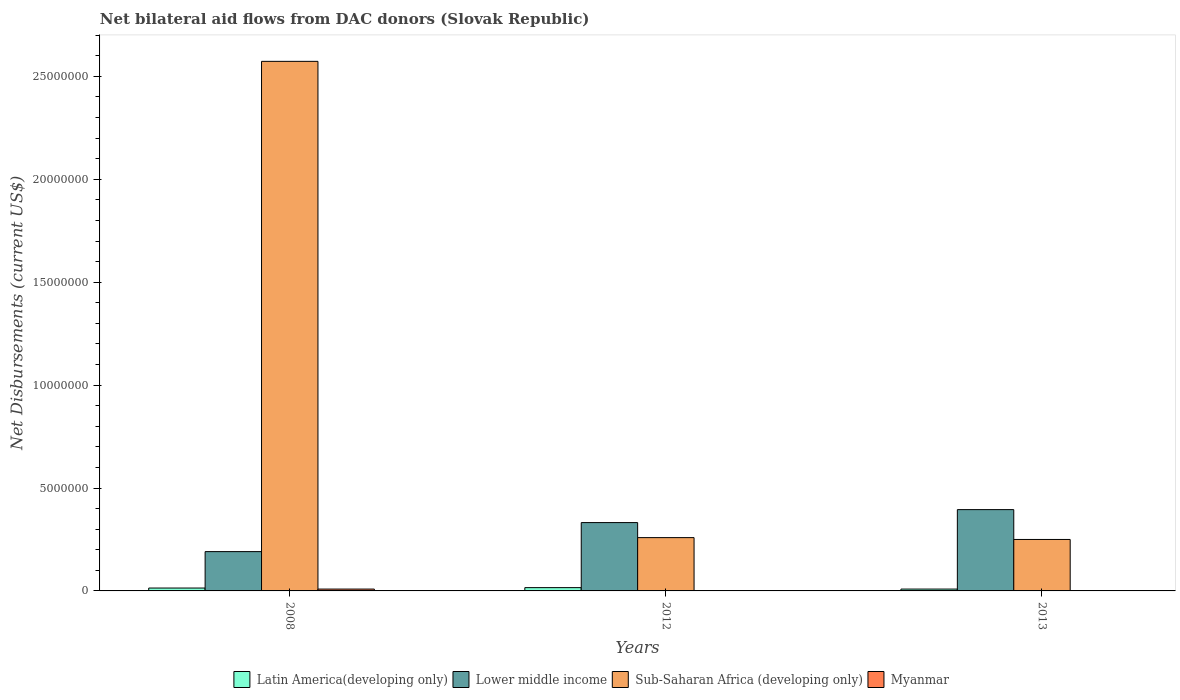Are the number of bars on each tick of the X-axis equal?
Keep it short and to the point. Yes. How many bars are there on the 3rd tick from the left?
Provide a succinct answer. 4. How many bars are there on the 3rd tick from the right?
Keep it short and to the point. 4. What is the label of the 1st group of bars from the left?
Provide a succinct answer. 2008. In how many cases, is the number of bars for a given year not equal to the number of legend labels?
Keep it short and to the point. 0. What is the net bilateral aid flows in Sub-Saharan Africa (developing only) in 2008?
Provide a succinct answer. 2.57e+07. Across all years, what is the minimum net bilateral aid flows in Sub-Saharan Africa (developing only)?
Offer a terse response. 2.50e+06. What is the difference between the net bilateral aid flows in Lower middle income in 2008 and the net bilateral aid flows in Sub-Saharan Africa (developing only) in 2013?
Offer a very short reply. -5.90e+05. In the year 2012, what is the difference between the net bilateral aid flows in Latin America(developing only) and net bilateral aid flows in Lower middle income?
Your answer should be compact. -3.16e+06. What is the ratio of the net bilateral aid flows in Lower middle income in 2012 to that in 2013?
Provide a succinct answer. 0.84. What is the difference between the highest and the lowest net bilateral aid flows in Myanmar?
Keep it short and to the point. 7.00e+04. In how many years, is the net bilateral aid flows in Latin America(developing only) greater than the average net bilateral aid flows in Latin America(developing only) taken over all years?
Your response must be concise. 2. What does the 1st bar from the left in 2008 represents?
Give a very brief answer. Latin America(developing only). What does the 1st bar from the right in 2012 represents?
Keep it short and to the point. Myanmar. Is it the case that in every year, the sum of the net bilateral aid flows in Lower middle income and net bilateral aid flows in Sub-Saharan Africa (developing only) is greater than the net bilateral aid flows in Latin America(developing only)?
Your answer should be compact. Yes. Are all the bars in the graph horizontal?
Ensure brevity in your answer.  No. How many years are there in the graph?
Provide a succinct answer. 3. Are the values on the major ticks of Y-axis written in scientific E-notation?
Keep it short and to the point. No. Does the graph contain grids?
Offer a very short reply. No. How many legend labels are there?
Make the answer very short. 4. How are the legend labels stacked?
Your answer should be compact. Horizontal. What is the title of the graph?
Your answer should be very brief. Net bilateral aid flows from DAC donors (Slovak Republic). Does "Tuvalu" appear as one of the legend labels in the graph?
Offer a very short reply. No. What is the label or title of the Y-axis?
Provide a succinct answer. Net Disbursements (current US$). What is the Net Disbursements (current US$) in Latin America(developing only) in 2008?
Ensure brevity in your answer.  1.40e+05. What is the Net Disbursements (current US$) in Lower middle income in 2008?
Ensure brevity in your answer.  1.91e+06. What is the Net Disbursements (current US$) of Sub-Saharan Africa (developing only) in 2008?
Offer a terse response. 2.57e+07. What is the Net Disbursements (current US$) in Myanmar in 2008?
Make the answer very short. 9.00e+04. What is the Net Disbursements (current US$) in Latin America(developing only) in 2012?
Your response must be concise. 1.60e+05. What is the Net Disbursements (current US$) in Lower middle income in 2012?
Your response must be concise. 3.32e+06. What is the Net Disbursements (current US$) in Sub-Saharan Africa (developing only) in 2012?
Offer a very short reply. 2.59e+06. What is the Net Disbursements (current US$) in Lower middle income in 2013?
Offer a terse response. 3.95e+06. What is the Net Disbursements (current US$) of Sub-Saharan Africa (developing only) in 2013?
Your answer should be very brief. 2.50e+06. What is the Net Disbursements (current US$) in Myanmar in 2013?
Your response must be concise. 2.00e+04. Across all years, what is the maximum Net Disbursements (current US$) in Latin America(developing only)?
Give a very brief answer. 1.60e+05. Across all years, what is the maximum Net Disbursements (current US$) of Lower middle income?
Provide a succinct answer. 3.95e+06. Across all years, what is the maximum Net Disbursements (current US$) of Sub-Saharan Africa (developing only)?
Provide a succinct answer. 2.57e+07. Across all years, what is the minimum Net Disbursements (current US$) of Lower middle income?
Provide a succinct answer. 1.91e+06. Across all years, what is the minimum Net Disbursements (current US$) of Sub-Saharan Africa (developing only)?
Give a very brief answer. 2.50e+06. What is the total Net Disbursements (current US$) of Lower middle income in the graph?
Give a very brief answer. 9.18e+06. What is the total Net Disbursements (current US$) in Sub-Saharan Africa (developing only) in the graph?
Provide a succinct answer. 3.08e+07. What is the difference between the Net Disbursements (current US$) of Lower middle income in 2008 and that in 2012?
Your response must be concise. -1.41e+06. What is the difference between the Net Disbursements (current US$) of Sub-Saharan Africa (developing only) in 2008 and that in 2012?
Offer a very short reply. 2.31e+07. What is the difference between the Net Disbursements (current US$) of Myanmar in 2008 and that in 2012?
Offer a terse response. 7.00e+04. What is the difference between the Net Disbursements (current US$) in Lower middle income in 2008 and that in 2013?
Your response must be concise. -2.04e+06. What is the difference between the Net Disbursements (current US$) of Sub-Saharan Africa (developing only) in 2008 and that in 2013?
Ensure brevity in your answer.  2.32e+07. What is the difference between the Net Disbursements (current US$) in Lower middle income in 2012 and that in 2013?
Offer a terse response. -6.30e+05. What is the difference between the Net Disbursements (current US$) in Myanmar in 2012 and that in 2013?
Offer a very short reply. 0. What is the difference between the Net Disbursements (current US$) in Latin America(developing only) in 2008 and the Net Disbursements (current US$) in Lower middle income in 2012?
Ensure brevity in your answer.  -3.18e+06. What is the difference between the Net Disbursements (current US$) in Latin America(developing only) in 2008 and the Net Disbursements (current US$) in Sub-Saharan Africa (developing only) in 2012?
Your response must be concise. -2.45e+06. What is the difference between the Net Disbursements (current US$) of Lower middle income in 2008 and the Net Disbursements (current US$) of Sub-Saharan Africa (developing only) in 2012?
Keep it short and to the point. -6.80e+05. What is the difference between the Net Disbursements (current US$) of Lower middle income in 2008 and the Net Disbursements (current US$) of Myanmar in 2012?
Your answer should be very brief. 1.89e+06. What is the difference between the Net Disbursements (current US$) in Sub-Saharan Africa (developing only) in 2008 and the Net Disbursements (current US$) in Myanmar in 2012?
Your answer should be compact. 2.57e+07. What is the difference between the Net Disbursements (current US$) of Latin America(developing only) in 2008 and the Net Disbursements (current US$) of Lower middle income in 2013?
Provide a short and direct response. -3.81e+06. What is the difference between the Net Disbursements (current US$) of Latin America(developing only) in 2008 and the Net Disbursements (current US$) of Sub-Saharan Africa (developing only) in 2013?
Offer a terse response. -2.36e+06. What is the difference between the Net Disbursements (current US$) of Lower middle income in 2008 and the Net Disbursements (current US$) of Sub-Saharan Africa (developing only) in 2013?
Your answer should be very brief. -5.90e+05. What is the difference between the Net Disbursements (current US$) of Lower middle income in 2008 and the Net Disbursements (current US$) of Myanmar in 2013?
Offer a terse response. 1.89e+06. What is the difference between the Net Disbursements (current US$) of Sub-Saharan Africa (developing only) in 2008 and the Net Disbursements (current US$) of Myanmar in 2013?
Ensure brevity in your answer.  2.57e+07. What is the difference between the Net Disbursements (current US$) in Latin America(developing only) in 2012 and the Net Disbursements (current US$) in Lower middle income in 2013?
Your answer should be compact. -3.79e+06. What is the difference between the Net Disbursements (current US$) of Latin America(developing only) in 2012 and the Net Disbursements (current US$) of Sub-Saharan Africa (developing only) in 2013?
Provide a short and direct response. -2.34e+06. What is the difference between the Net Disbursements (current US$) in Lower middle income in 2012 and the Net Disbursements (current US$) in Sub-Saharan Africa (developing only) in 2013?
Your answer should be compact. 8.20e+05. What is the difference between the Net Disbursements (current US$) of Lower middle income in 2012 and the Net Disbursements (current US$) of Myanmar in 2013?
Make the answer very short. 3.30e+06. What is the difference between the Net Disbursements (current US$) in Sub-Saharan Africa (developing only) in 2012 and the Net Disbursements (current US$) in Myanmar in 2013?
Offer a terse response. 2.57e+06. What is the average Net Disbursements (current US$) of Latin America(developing only) per year?
Offer a terse response. 1.30e+05. What is the average Net Disbursements (current US$) of Lower middle income per year?
Provide a succinct answer. 3.06e+06. What is the average Net Disbursements (current US$) in Sub-Saharan Africa (developing only) per year?
Make the answer very short. 1.03e+07. What is the average Net Disbursements (current US$) of Myanmar per year?
Provide a succinct answer. 4.33e+04. In the year 2008, what is the difference between the Net Disbursements (current US$) of Latin America(developing only) and Net Disbursements (current US$) of Lower middle income?
Make the answer very short. -1.77e+06. In the year 2008, what is the difference between the Net Disbursements (current US$) in Latin America(developing only) and Net Disbursements (current US$) in Sub-Saharan Africa (developing only)?
Offer a very short reply. -2.56e+07. In the year 2008, what is the difference between the Net Disbursements (current US$) of Lower middle income and Net Disbursements (current US$) of Sub-Saharan Africa (developing only)?
Your answer should be compact. -2.38e+07. In the year 2008, what is the difference between the Net Disbursements (current US$) of Lower middle income and Net Disbursements (current US$) of Myanmar?
Provide a succinct answer. 1.82e+06. In the year 2008, what is the difference between the Net Disbursements (current US$) in Sub-Saharan Africa (developing only) and Net Disbursements (current US$) in Myanmar?
Give a very brief answer. 2.56e+07. In the year 2012, what is the difference between the Net Disbursements (current US$) of Latin America(developing only) and Net Disbursements (current US$) of Lower middle income?
Offer a terse response. -3.16e+06. In the year 2012, what is the difference between the Net Disbursements (current US$) of Latin America(developing only) and Net Disbursements (current US$) of Sub-Saharan Africa (developing only)?
Offer a very short reply. -2.43e+06. In the year 2012, what is the difference between the Net Disbursements (current US$) in Lower middle income and Net Disbursements (current US$) in Sub-Saharan Africa (developing only)?
Make the answer very short. 7.30e+05. In the year 2012, what is the difference between the Net Disbursements (current US$) of Lower middle income and Net Disbursements (current US$) of Myanmar?
Your answer should be very brief. 3.30e+06. In the year 2012, what is the difference between the Net Disbursements (current US$) of Sub-Saharan Africa (developing only) and Net Disbursements (current US$) of Myanmar?
Ensure brevity in your answer.  2.57e+06. In the year 2013, what is the difference between the Net Disbursements (current US$) of Latin America(developing only) and Net Disbursements (current US$) of Lower middle income?
Make the answer very short. -3.86e+06. In the year 2013, what is the difference between the Net Disbursements (current US$) of Latin America(developing only) and Net Disbursements (current US$) of Sub-Saharan Africa (developing only)?
Offer a very short reply. -2.41e+06. In the year 2013, what is the difference between the Net Disbursements (current US$) of Latin America(developing only) and Net Disbursements (current US$) of Myanmar?
Your response must be concise. 7.00e+04. In the year 2013, what is the difference between the Net Disbursements (current US$) of Lower middle income and Net Disbursements (current US$) of Sub-Saharan Africa (developing only)?
Keep it short and to the point. 1.45e+06. In the year 2013, what is the difference between the Net Disbursements (current US$) in Lower middle income and Net Disbursements (current US$) in Myanmar?
Your answer should be compact. 3.93e+06. In the year 2013, what is the difference between the Net Disbursements (current US$) in Sub-Saharan Africa (developing only) and Net Disbursements (current US$) in Myanmar?
Offer a very short reply. 2.48e+06. What is the ratio of the Net Disbursements (current US$) in Latin America(developing only) in 2008 to that in 2012?
Offer a very short reply. 0.88. What is the ratio of the Net Disbursements (current US$) of Lower middle income in 2008 to that in 2012?
Offer a very short reply. 0.58. What is the ratio of the Net Disbursements (current US$) of Sub-Saharan Africa (developing only) in 2008 to that in 2012?
Ensure brevity in your answer.  9.93. What is the ratio of the Net Disbursements (current US$) of Myanmar in 2008 to that in 2012?
Give a very brief answer. 4.5. What is the ratio of the Net Disbursements (current US$) of Latin America(developing only) in 2008 to that in 2013?
Provide a succinct answer. 1.56. What is the ratio of the Net Disbursements (current US$) of Lower middle income in 2008 to that in 2013?
Ensure brevity in your answer.  0.48. What is the ratio of the Net Disbursements (current US$) of Sub-Saharan Africa (developing only) in 2008 to that in 2013?
Ensure brevity in your answer.  10.29. What is the ratio of the Net Disbursements (current US$) in Myanmar in 2008 to that in 2013?
Ensure brevity in your answer.  4.5. What is the ratio of the Net Disbursements (current US$) in Latin America(developing only) in 2012 to that in 2013?
Offer a terse response. 1.78. What is the ratio of the Net Disbursements (current US$) in Lower middle income in 2012 to that in 2013?
Provide a short and direct response. 0.84. What is the ratio of the Net Disbursements (current US$) of Sub-Saharan Africa (developing only) in 2012 to that in 2013?
Provide a succinct answer. 1.04. What is the difference between the highest and the second highest Net Disbursements (current US$) in Lower middle income?
Give a very brief answer. 6.30e+05. What is the difference between the highest and the second highest Net Disbursements (current US$) of Sub-Saharan Africa (developing only)?
Ensure brevity in your answer.  2.31e+07. What is the difference between the highest and the lowest Net Disbursements (current US$) of Lower middle income?
Your response must be concise. 2.04e+06. What is the difference between the highest and the lowest Net Disbursements (current US$) of Sub-Saharan Africa (developing only)?
Provide a short and direct response. 2.32e+07. 